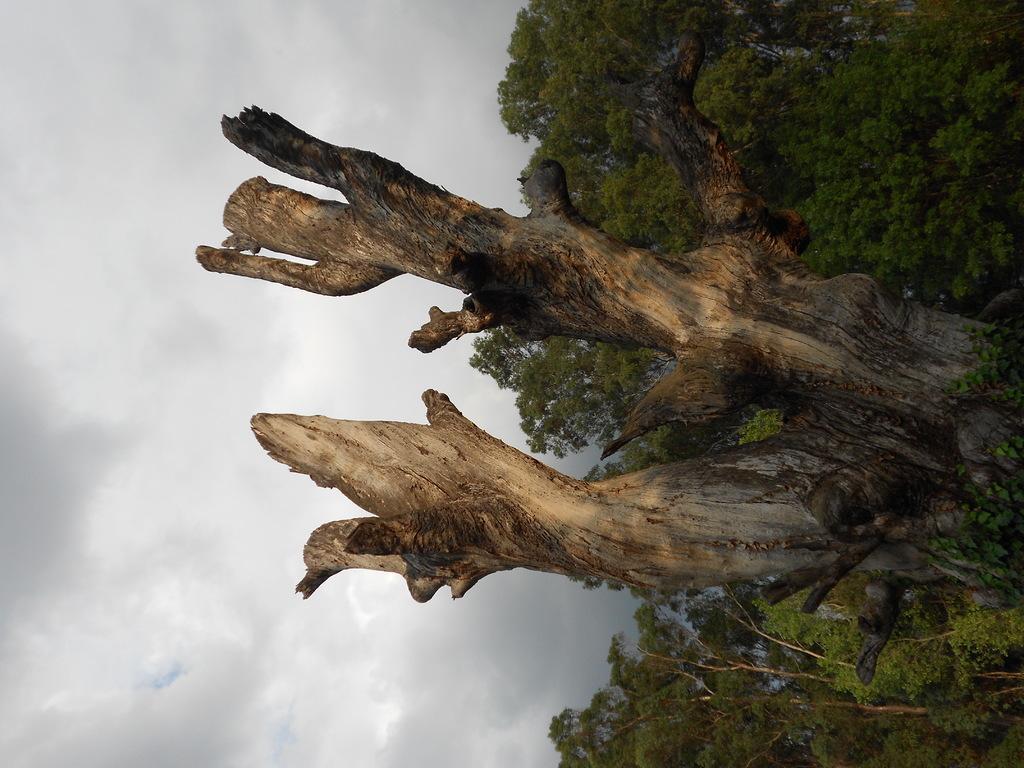How would you summarize this image in a sentence or two? In this image there are trees and a log, in the background there is the cloudy sky. 